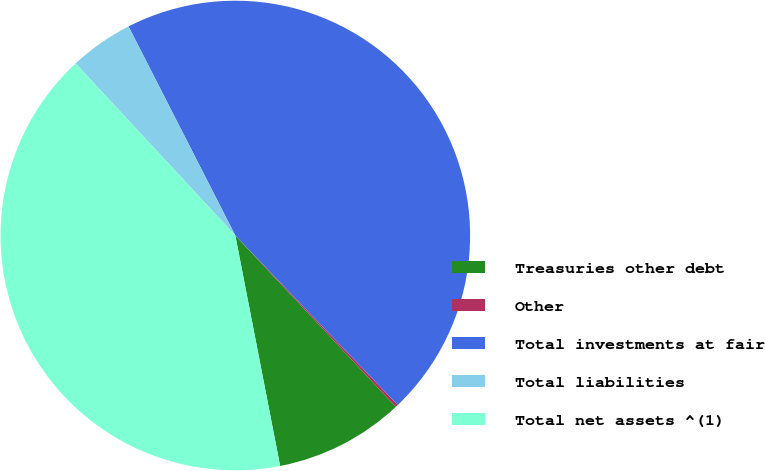<chart> <loc_0><loc_0><loc_500><loc_500><pie_chart><fcel>Treasuries other debt<fcel>Other<fcel>Total investments at fair<fcel>Total liabilities<fcel>Total net assets ^(1)<nl><fcel>8.92%<fcel>0.18%<fcel>45.36%<fcel>4.39%<fcel>41.15%<nl></chart> 